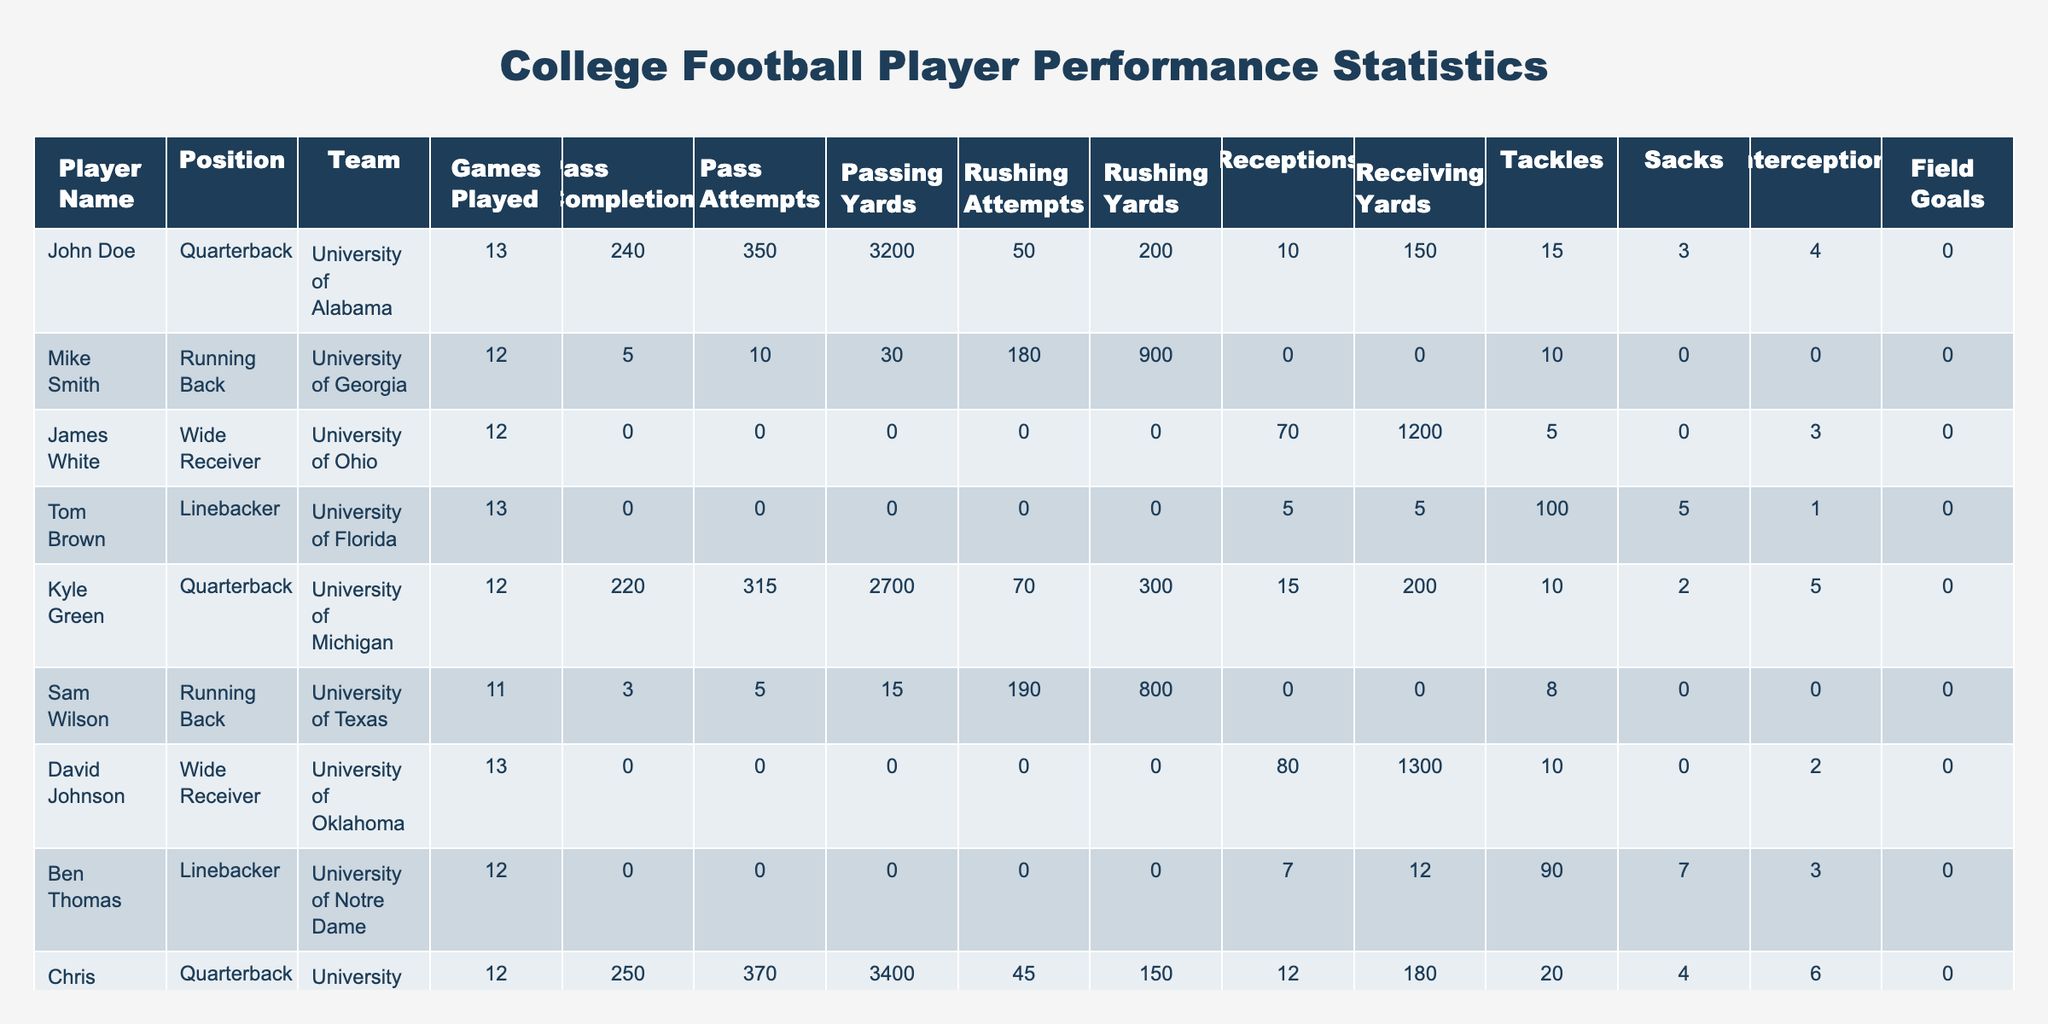What is the total number of passing yards for all quarterbacks in the table? The quarterbacks in the table are John Doe, Kyle Green, and Chris Evans. Their passing yards are 3200, 2700, and 3400 respectively. To find the total, we sum these values: 3200 + 2700 + 3400 = 9300.
Answer: 9300 Which player has the highest number of receptions? From the table, James White has the highest number of receptions with 70, while other players have fewer. Therefore, the answer is 70.
Answer: 70 Did any player kick field goals in this season? The field goals column shows that all entries have a value of 0, indicating no player successfully kicked any field goals this season.
Answer: No What is the average rushing yards for the running backs listed? The running backs are Mike Smith with 900 rushing yards, Sam Wilson with 800, and Eli Brown with 600. We calculate the average as follows: (900 + 800 + 600) / 3 = 766.67, rounding down gives us 766 when considering whole yards.
Answer: 766 Which team had the quarterback with the most passing attempts? By examining the table, Chris Evans from the University of Oregon has the most passing attempts at 370. None of the other quarterbacks exceed this.
Answer: University of Oregon How many players had more than 100 tackles? Checking the tackles column, only Tom Brown and Ben Thomas are listed with tackles higher than 100, with Tom Brown at 100 and Ben Thomas at 90. Thus, only Tom Brown qualifies.
Answer: 1 What is the difference in passing yards between the highest and lowest quarterback? John Doe has 3200 yards and Kyle Green has 2700. The difference is calculated as 3200 - 2700 = 500 yards.
Answer: 500 How many total games did all players play combined? The total games played can be summed by adding the games played by each player: 13 + 12 + 12 + 13 + 12 + 11 + 13 + 12 + 10 + 14 = 129.
Answer: 129 Was there a wide receiver who did not catch any passes? From the data, we see that both David Johnson and Adam Johnson recorded zero receptions. Therefore, the answer is yes.
Answer: Yes What is the total number of interceptions thrown by quarterbacks? The interceptions for these quarterbacks are 4 (John Doe), 5 (Kyle Green), and 6 (Chris Evans). Therefore, the total is 4 + 5 + 6 = 15 interceptions.
Answer: 15 Which team’s players had the least total rushing yards? The table shows each player's rushing yards. Mike Smith from University of Georgia had 900, Sam Wilson from University of Texas had 800, and Eli Brown from University of Miami had 600. The lowest is Eli Brown at 600 yards.
Answer: University of Miami 